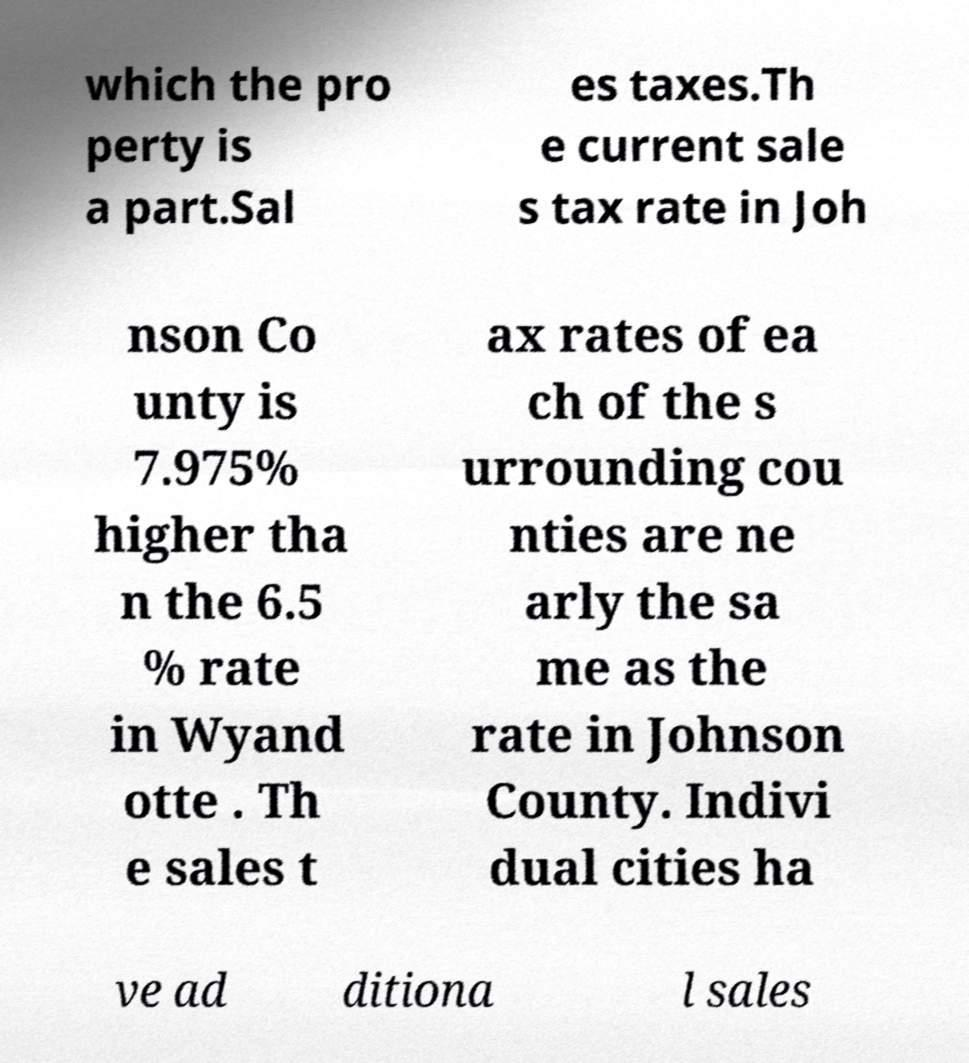Please identify and transcribe the text found in this image. which the pro perty is a part.Sal es taxes.Th e current sale s tax rate in Joh nson Co unty is 7.975% higher tha n the 6.5 % rate in Wyand otte . Th e sales t ax rates of ea ch of the s urrounding cou nties are ne arly the sa me as the rate in Johnson County. Indivi dual cities ha ve ad ditiona l sales 